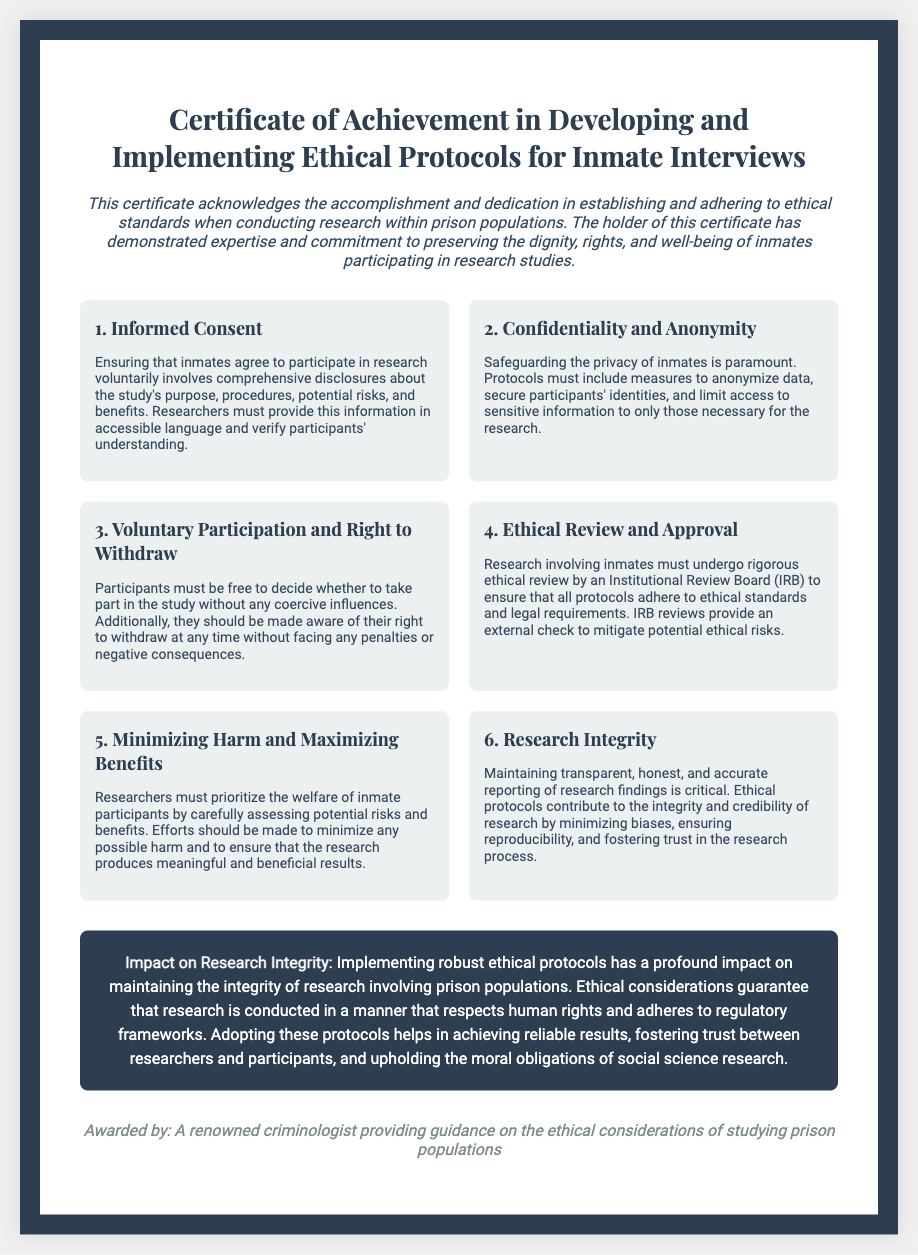What is the title of the certificate? The title is the main heading displayed at the top of the document, which is "Certificate of Achievement in Developing and Implementing Ethical Protocols for Inmate Interviews."
Answer: Certificate of Achievement in Developing and Implementing Ethical Protocols for Inmate Interviews What is the significance of informed consent? Informed consent is essential as it involves ensuring that inmates agree to participate voluntarily with comprehensive disclosures about the study's purpose, procedures, potential risks, and benefits.
Answer: Ensuring voluntary participation How many sections are listed that discuss ethical protocols? The document contains six sections that discuss different ethical protocols relevant to inmate interviews.
Answer: Six What does the impact section emphasize? The impact section emphasizes the importance of implementing robust ethical protocols to maintain the integrity of research involving prison populations.
Answer: Maintaining research integrity Who awarded the certificate? The signature at the bottom of the document indicates that the certificate is awarded by a renowned criminologist providing guidance on the ethical considerations of studying prison populations.
Answer: A renowned criminologist 